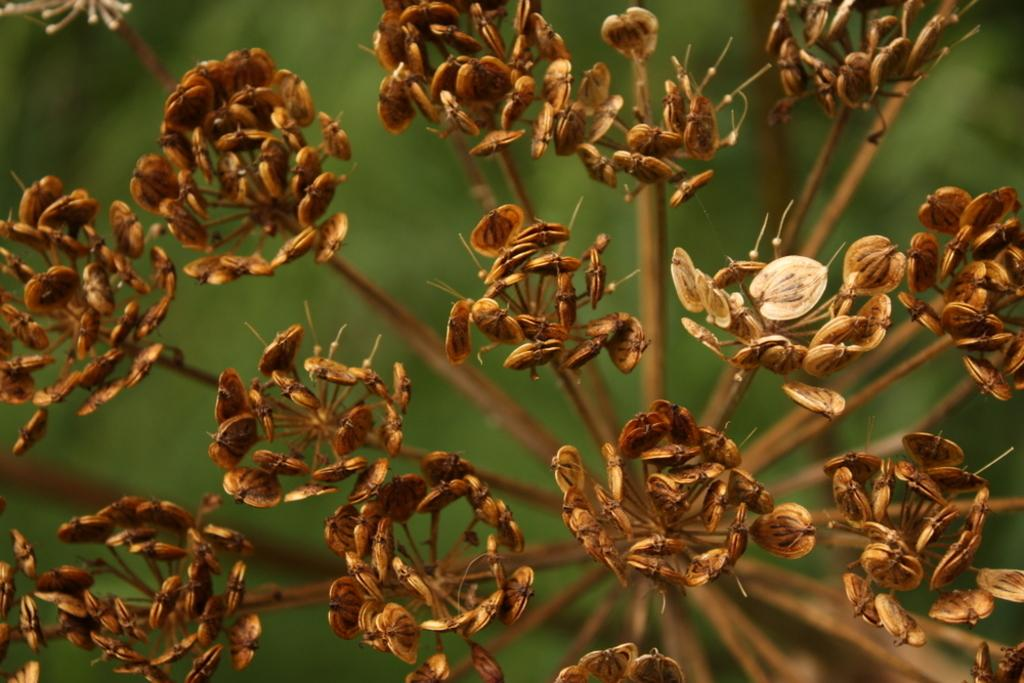What type of flowers are present in the image? The image contains dried flowers. What is the source of the dried flowers? The dried flowers are from a plant. What type of garden can be seen in the image? There is no garden present in the image; it only contains dried flowers from a plant. What reward is being given to the scarecrow in the image? There is no scarecrow or reward present in the image; it only contains dried flowers from a plant. 